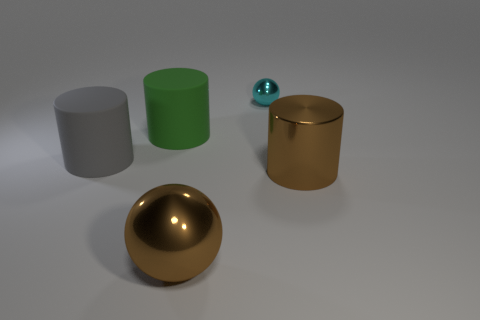There is a object that is both on the right side of the large green cylinder and to the left of the tiny cyan ball; what material is it?
Offer a very short reply. Metal. The cyan metal sphere has what size?
Offer a very short reply. Small. Is the color of the metallic cylinder the same as the sphere in front of the metal cylinder?
Provide a succinct answer. Yes. How many other things are there of the same color as the tiny shiny object?
Your answer should be very brief. 0. There is a brown metal thing behind the big brown metal sphere; does it have the same size as the shiny thing that is in front of the brown cylinder?
Give a very brief answer. Yes. What is the color of the large object to the right of the large metallic ball?
Provide a short and direct response. Brown. Is the number of big matte cylinders that are behind the large gray rubber cylinder less than the number of cyan things?
Provide a short and direct response. No. Are the brown sphere and the tiny cyan sphere made of the same material?
Provide a succinct answer. Yes. There is another thing that is the same shape as the small cyan thing; what is its size?
Provide a succinct answer. Large. What number of things are either rubber cylinders right of the gray cylinder or big matte cylinders that are behind the gray cylinder?
Your answer should be very brief. 1. 